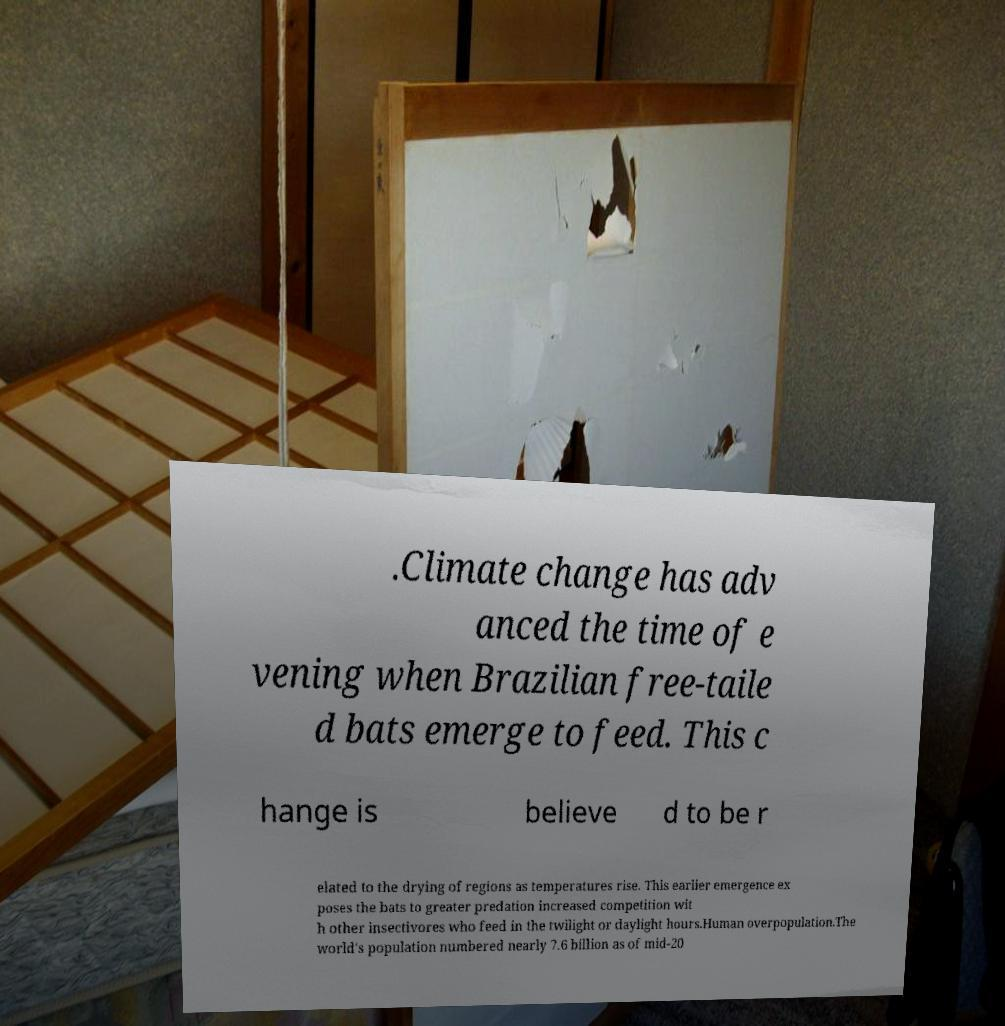Can you read and provide the text displayed in the image?This photo seems to have some interesting text. Can you extract and type it out for me? .Climate change has adv anced the time of e vening when Brazilian free-taile d bats emerge to feed. This c hange is believe d to be r elated to the drying of regions as temperatures rise. This earlier emergence ex poses the bats to greater predation increased competition wit h other insectivores who feed in the twilight or daylight hours.Human overpopulation.The world's population numbered nearly 7.6 billion as of mid-20 